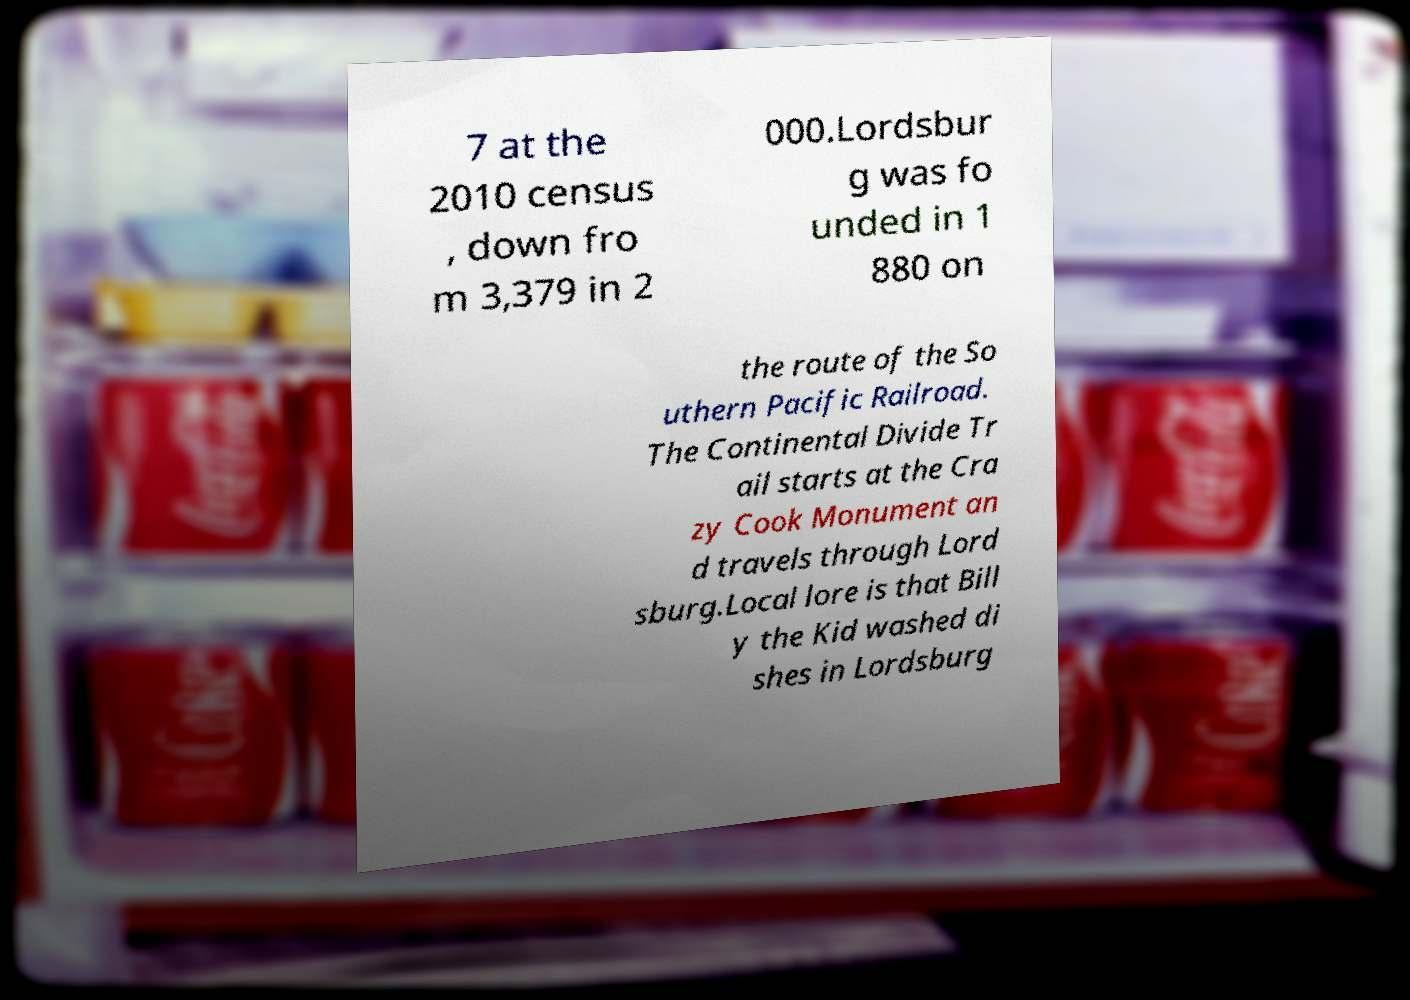Please read and relay the text visible in this image. What does it say? 7 at the 2010 census , down fro m 3,379 in 2 000.Lordsbur g was fo unded in 1 880 on the route of the So uthern Pacific Railroad. The Continental Divide Tr ail starts at the Cra zy Cook Monument an d travels through Lord sburg.Local lore is that Bill y the Kid washed di shes in Lordsburg 